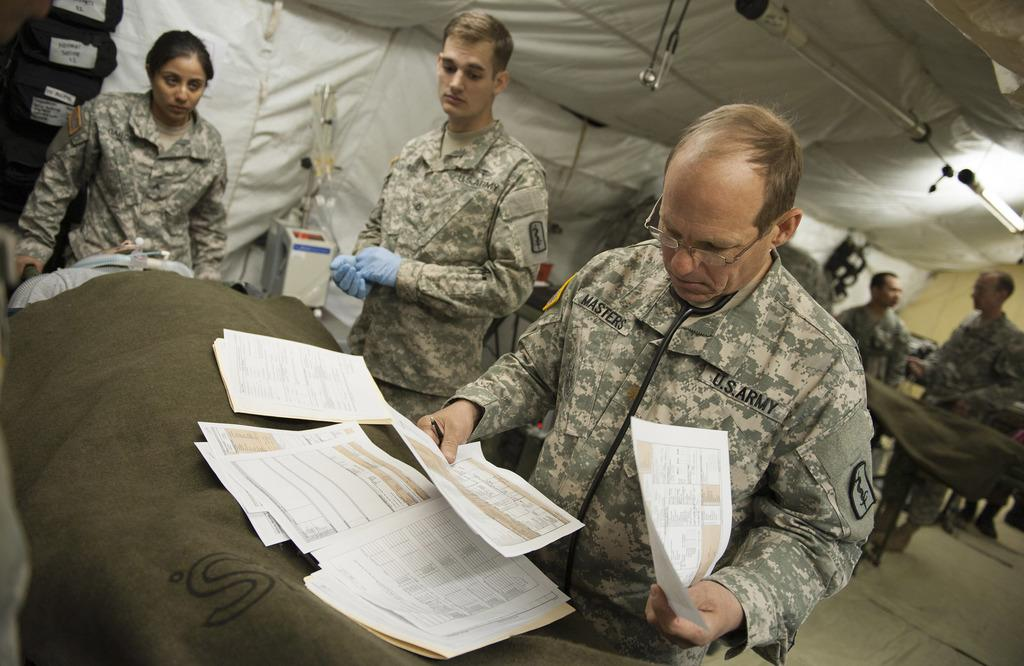How many people are in the image? There are many people in the image. What are the people wearing? The people are wearing military dresses. Can you describe the person in the front? The person in the front is holding papers. What is in front of the person holding papers? There are papers in front of the person holding them. Is there any snow visible in the image? No, there is no snow present in the image. What position does the person in the front hold in the military? The image does not provide enough information to determine the person's rank or position in the military. 